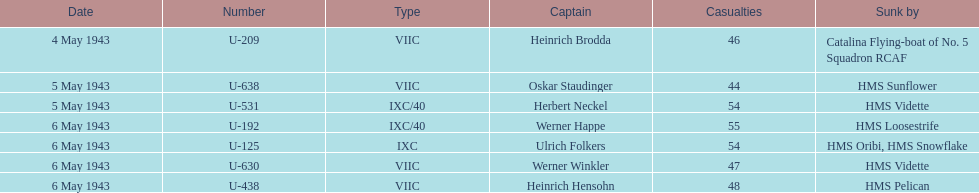Which u-boat was the pioneer in sinking? U-209. 